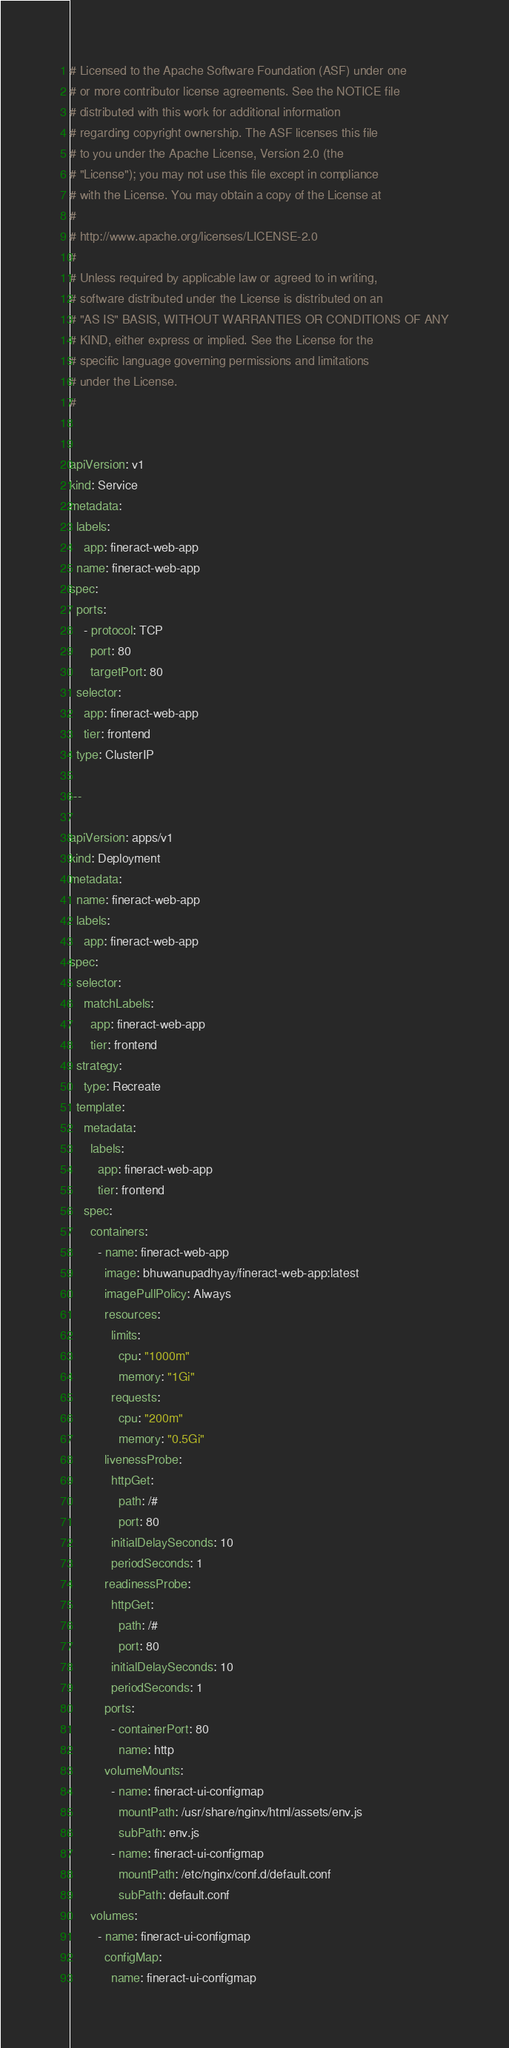<code> <loc_0><loc_0><loc_500><loc_500><_YAML_># Licensed to the Apache Software Foundation (ASF) under one
# or more contributor license agreements. See the NOTICE file
# distributed with this work for additional information
# regarding copyright ownership. The ASF licenses this file
# to you under the Apache License, Version 2.0 (the
# "License"); you may not use this file except in compliance
# with the License. You may obtain a copy of the License at
#
# http://www.apache.org/licenses/LICENSE-2.0
#
# Unless required by applicable law or agreed to in writing,
# software distributed under the License is distributed on an
# "AS IS" BASIS, WITHOUT WARRANTIES OR CONDITIONS OF ANY
# KIND, either express or implied. See the License for the
# specific language governing permissions and limitations
# under the License.
#


apiVersion: v1
kind: Service
metadata:
  labels:
    app: fineract-web-app
  name: fineract-web-app
spec:
  ports:
    - protocol: TCP
      port: 80
      targetPort: 80
  selector:
    app: fineract-web-app
    tier: frontend
  type: ClusterIP

---

apiVersion: apps/v1
kind: Deployment
metadata:
  name: fineract-web-app
  labels:
    app: fineract-web-app
spec:
  selector:
    matchLabels:
      app: fineract-web-app
      tier: frontend
  strategy:
    type: Recreate
  template:
    metadata:
      labels:
        app: fineract-web-app
        tier: frontend
    spec:
      containers:
        - name: fineract-web-app
          image: bhuwanupadhyay/fineract-web-app:latest
          imagePullPolicy: Always
          resources:
            limits:
              cpu: "1000m"
              memory: "1Gi"
            requests:
              cpu: "200m"
              memory: "0.5Gi"
          livenessProbe:
            httpGet:
              path: /#
              port: 80
            initialDelaySeconds: 10
            periodSeconds: 1
          readinessProbe:
            httpGet:
              path: /#
              port: 80
            initialDelaySeconds: 10
            periodSeconds: 1
          ports:
            - containerPort: 80
              name: http
          volumeMounts:
            - name: fineract-ui-configmap
              mountPath: /usr/share/nginx/html/assets/env.js
              subPath: env.js
            - name: fineract-ui-configmap
              mountPath: /etc/nginx/conf.d/default.conf
              subPath: default.conf
      volumes:
        - name: fineract-ui-configmap
          configMap:
            name: fineract-ui-configmap
</code> 